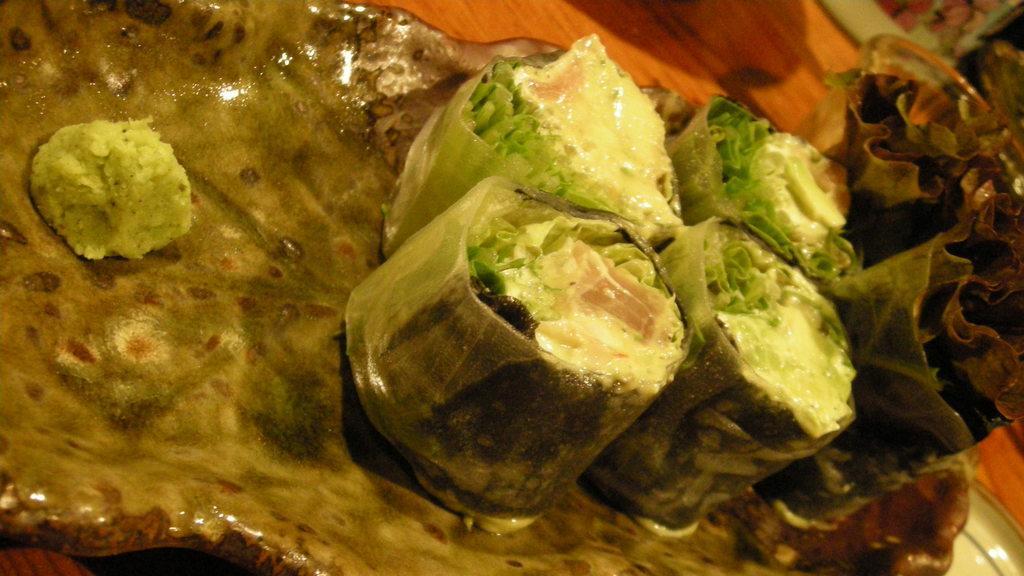How would you summarize this image in a sentence or two? Here we can see food items in a plate on a table and we can also see some other items on the table. 